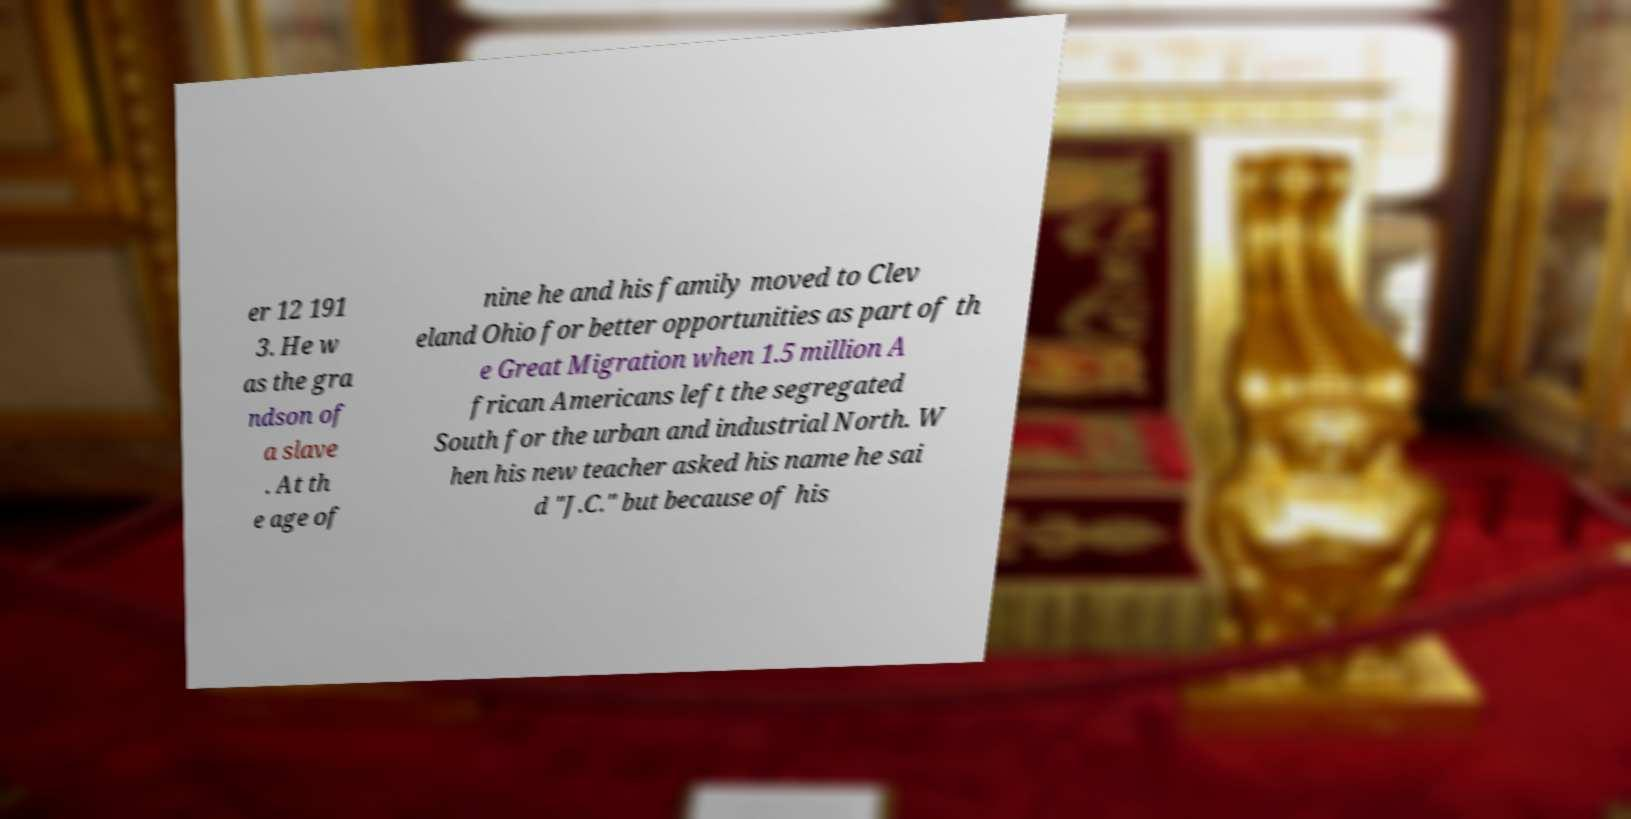Could you assist in decoding the text presented in this image and type it out clearly? er 12 191 3. He w as the gra ndson of a slave . At th e age of nine he and his family moved to Clev eland Ohio for better opportunities as part of th e Great Migration when 1.5 million A frican Americans left the segregated South for the urban and industrial North. W hen his new teacher asked his name he sai d "J.C." but because of his 